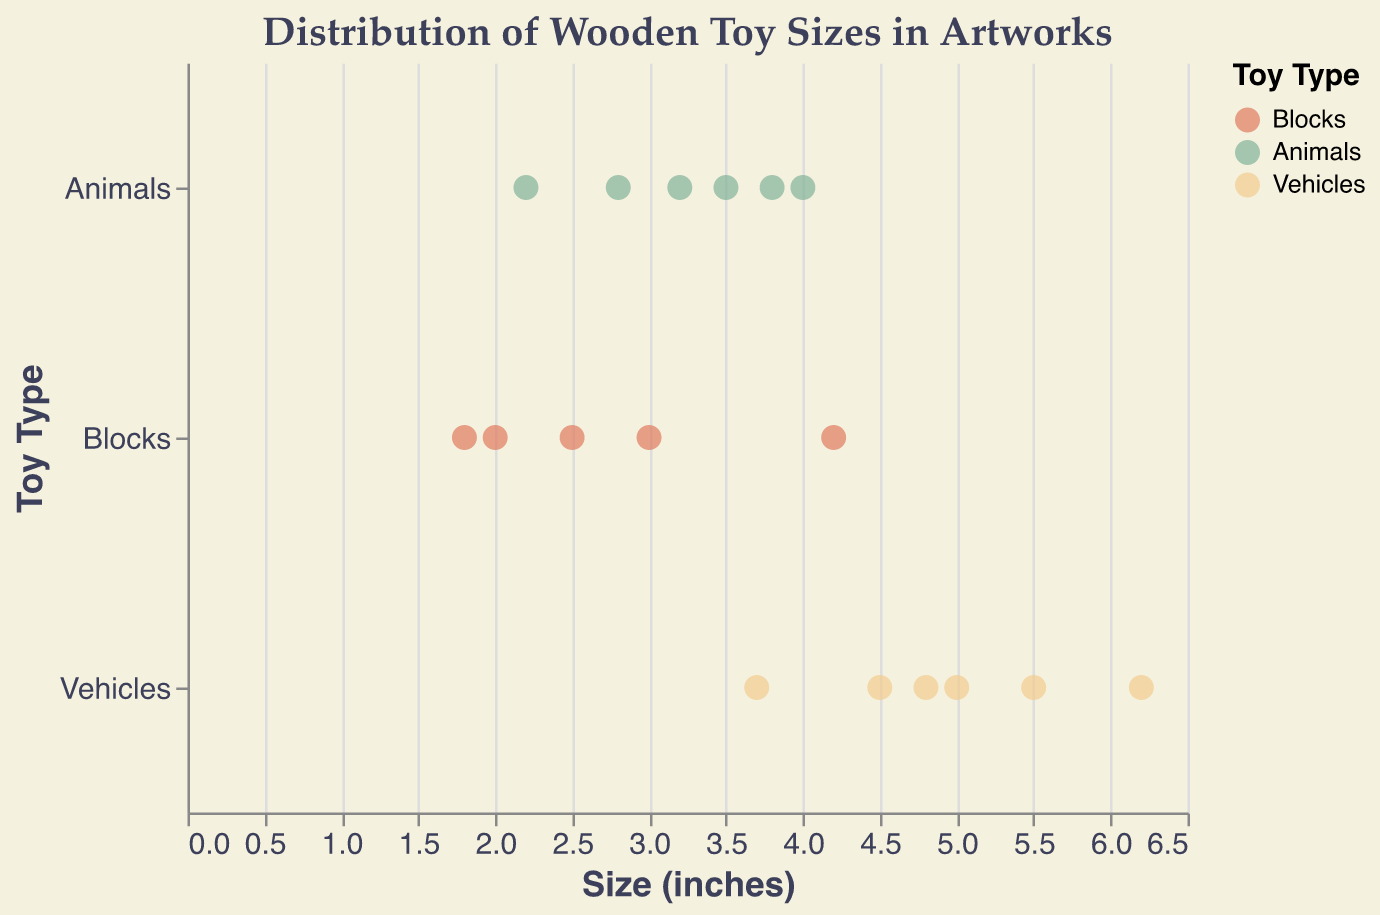What are the average sizes of each type of toy? Calculate the average size for each toy type. For Blocks, sum the sizes (2.5 + 3.0 + 1.8 + 4.2 + 2.0) and divide by the number of toys (5). For Animals, sum the sizes (3.5 + 2.8 + 4.0 + 2.2 + 3.2 + 3.8) and divide by the number of toys (6). For Vehicles, sum the sizes (5.5 + 4.8 + 3.7 + 6.2 + 4.5 + 5.0) and divide by the number of toys (6).
Answer: Blocks: 2.7, Animals: 3.25, Vehicles: 4.95 Which toy type has the largest size? Identify the toy with the largest size (6.2 inches) and its type (Vehicles).
Answer: Vehicles How many toys are in each type category? Count the number of toys in each category. There are 5 Blocks, 6 Animals, and 6 Vehicles.
Answer: Blocks: 5, Animals: 6, Vehicles: 6 What is the range of sizes for the 'Animals' type? Identify the smallest (2.2 inches) and largest (4.0 inches) sizes for the Animals category, then calculate the range by subtracting the smallest from the largest.
Answer: Range: 1.8 inches Which toy has the smallest size, and what type is it? Locate the toy with the smallest size (1.8 inches) and note its type (Blocks).
Answer: Oak Triangle (Blocks) How does the average size of Vehicles compare to that of Blocks? Calculate the difference between the average sizes of Vehicles (4.95 inches) and Blocks (2.7 inches).
Answer: Vehicles' average size is 2.25 inches larger than Blocks' Are there more toys in the 'Animals' category that are larger than 3 inches or smaller than 3 inches? Count the number of 'Animals' toys larger than 3 inches (3) and the number smaller than 3 inches (3).
Answer: Equal, 3 larger and 3 smaller How does the variation in size differ between Blocks and Vehicles? Calculate the range for Blocks (smallest: 1.8, largest: 4.2, range: 2.4 inches) and for Vehicles (smallest: 3.7, largest: 6.2, range: 2.5 inches).
Answer: Vehicles vary slightly more than Blocks by 0.1 inches 